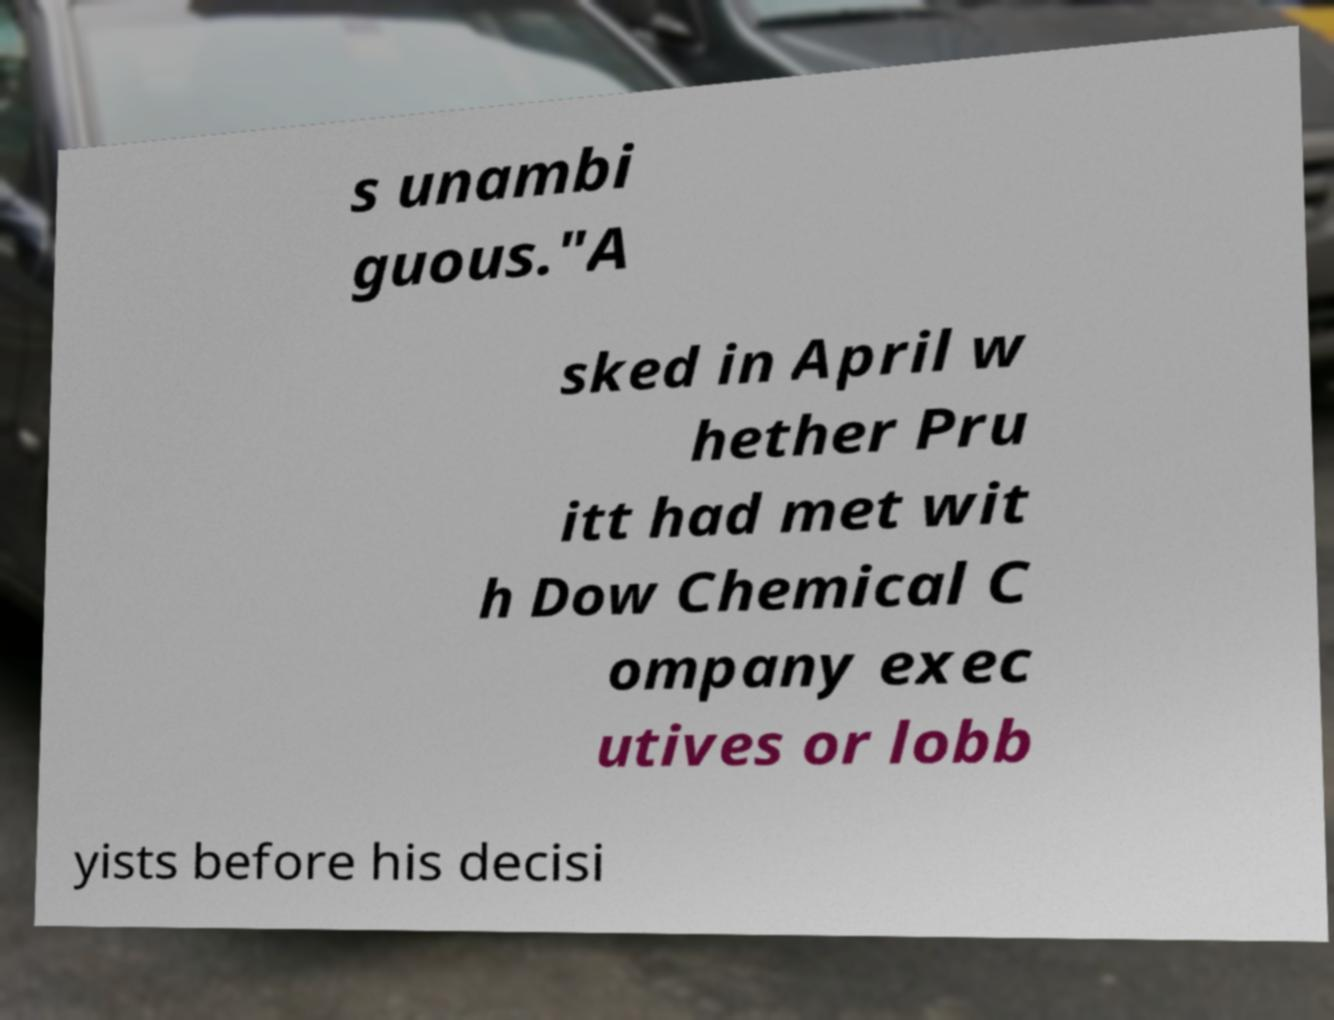Please read and relay the text visible in this image. What does it say? s unambi guous."A sked in April w hether Pru itt had met wit h Dow Chemical C ompany exec utives or lobb yists before his decisi 